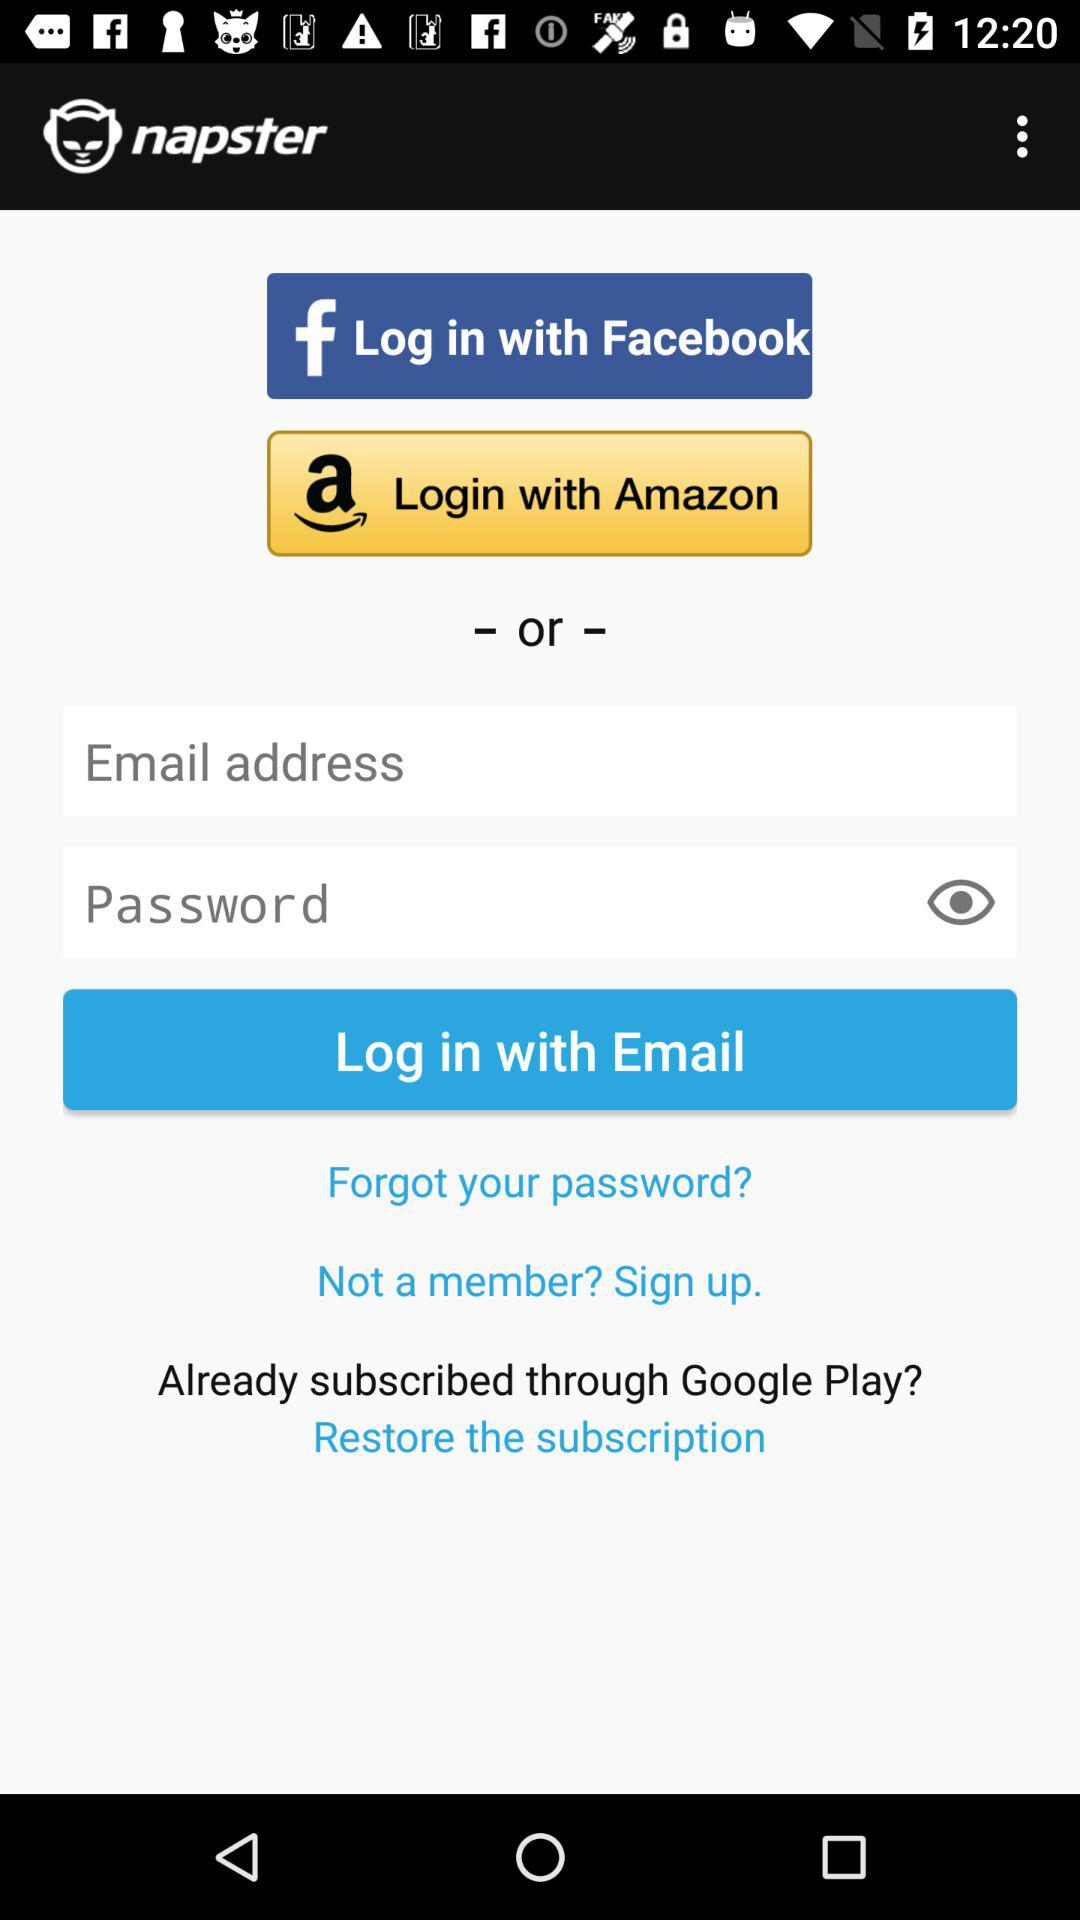What are the account options for logging in? The account options for logging in are "Facebook", "Amazon" and "Email". 